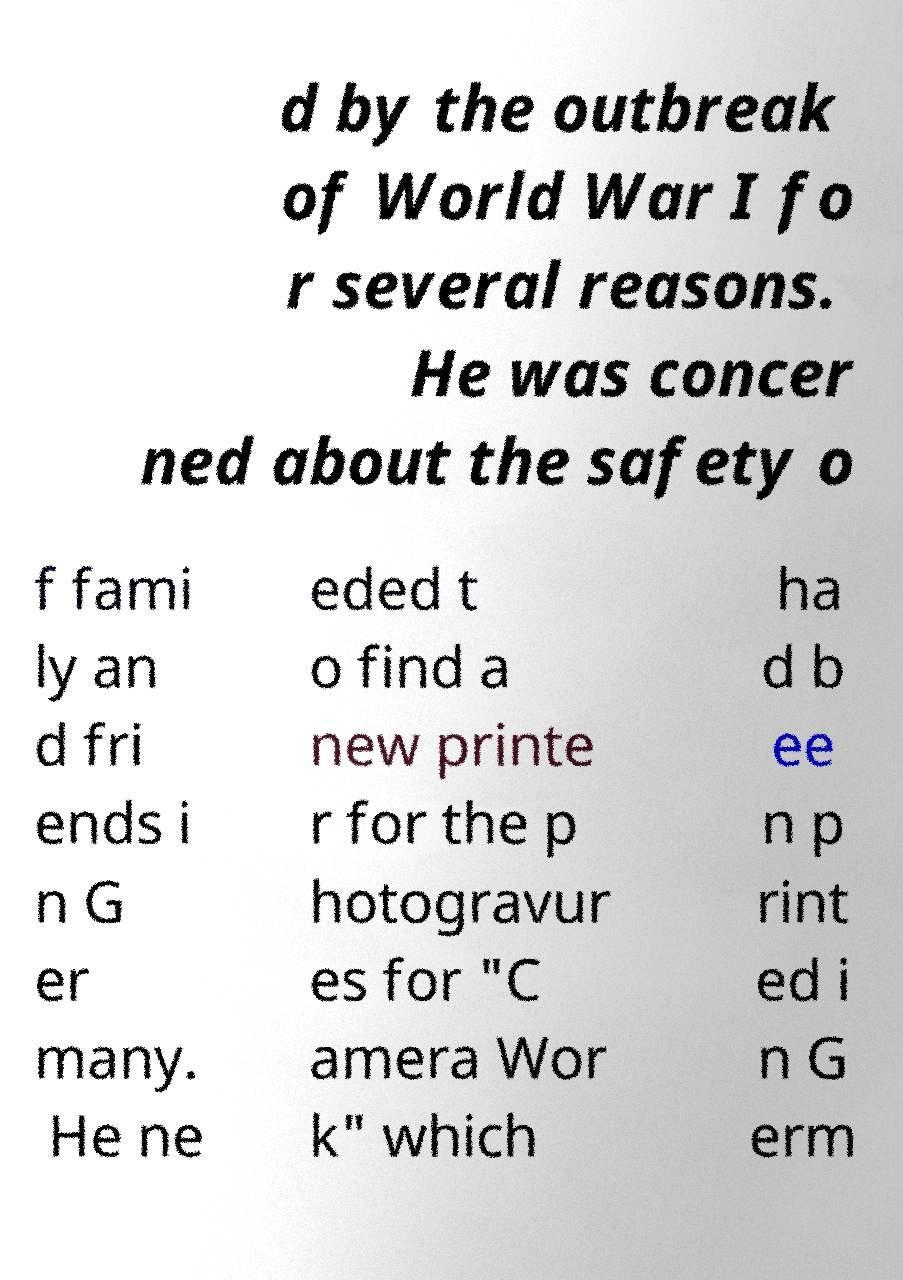What messages or text are displayed in this image? I need them in a readable, typed format. d by the outbreak of World War I fo r several reasons. He was concer ned about the safety o f fami ly an d fri ends i n G er many. He ne eded t o find a new printe r for the p hotogravur es for "C amera Wor k" which ha d b ee n p rint ed i n G erm 